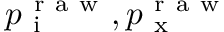<formula> <loc_0><loc_0><loc_500><loc_500>p _ { i } ^ { r a w } , p _ { x } ^ { r a w }</formula> 